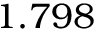Convert formula to latex. <formula><loc_0><loc_0><loc_500><loc_500>1 . 7 9 8</formula> 